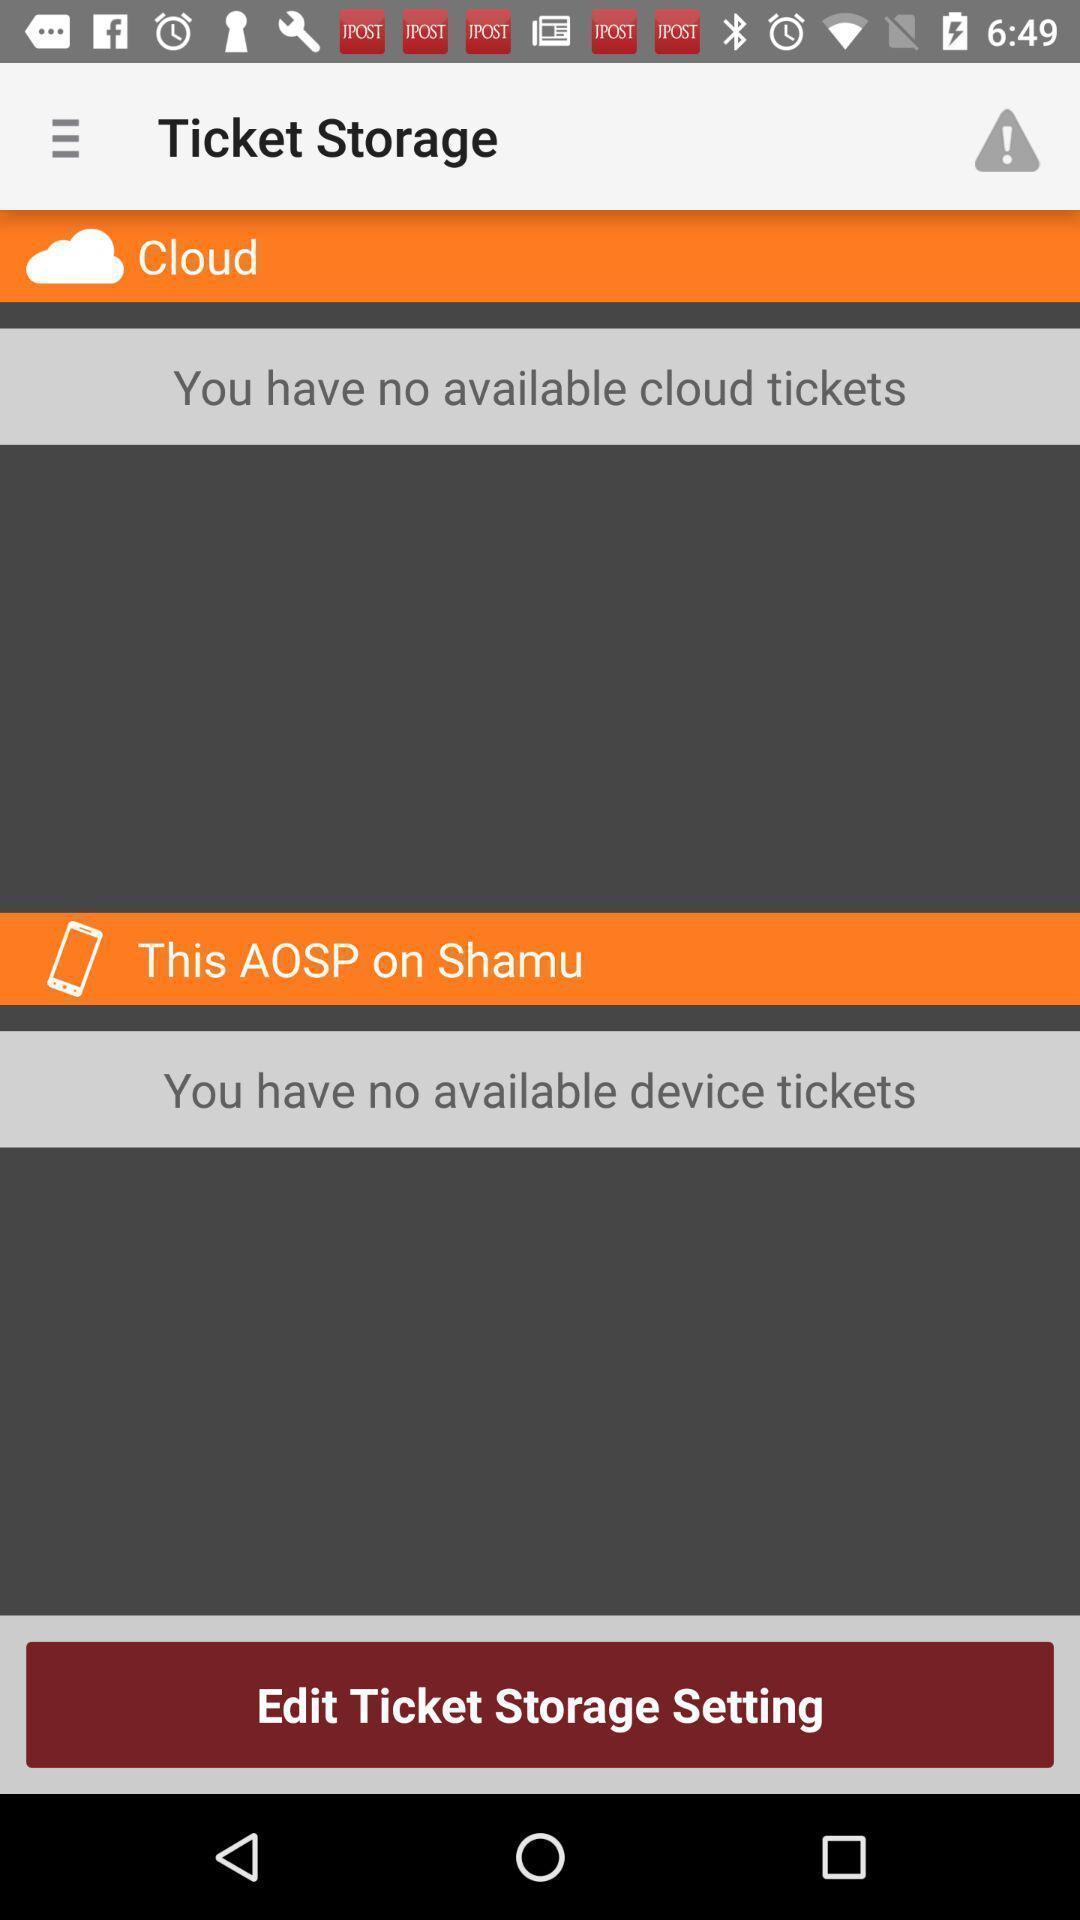What is the overall content of this screenshot? Page is showing you have no available cloud tickets. 